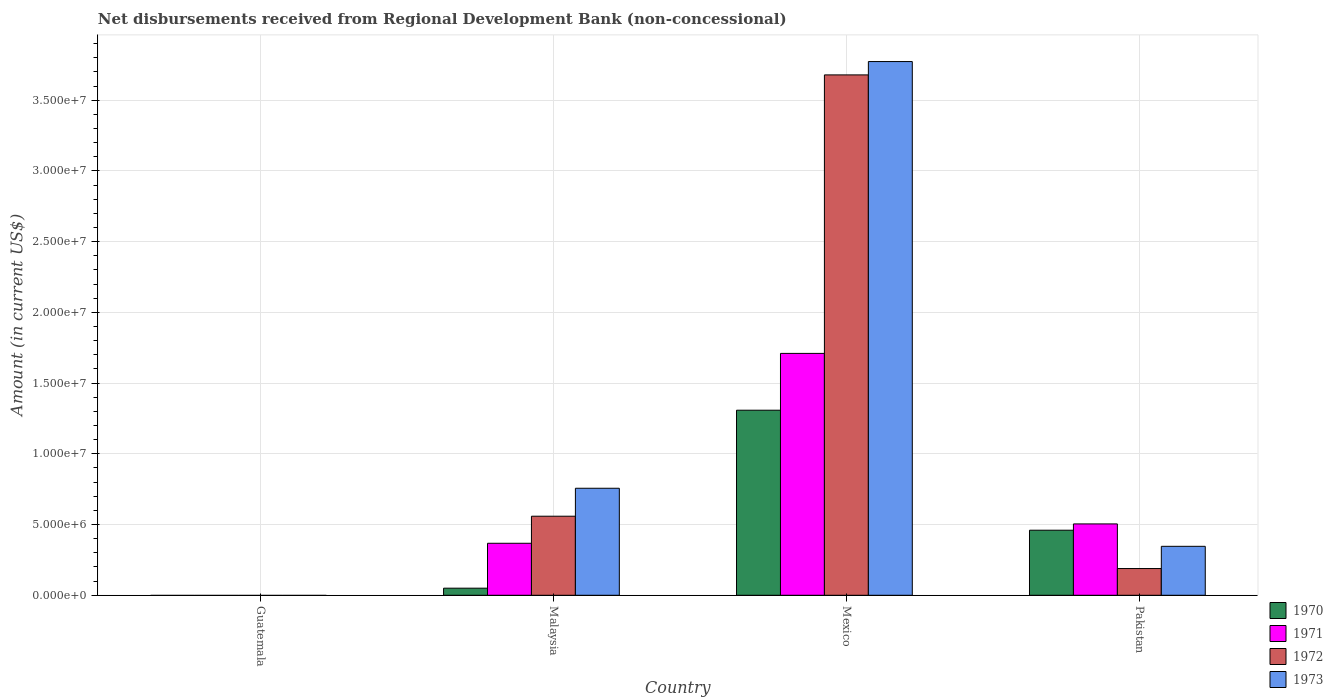How many bars are there on the 2nd tick from the left?
Your answer should be compact. 4. How many bars are there on the 2nd tick from the right?
Keep it short and to the point. 4. What is the amount of disbursements received from Regional Development Bank in 1973 in Mexico?
Your response must be concise. 3.77e+07. Across all countries, what is the maximum amount of disbursements received from Regional Development Bank in 1972?
Keep it short and to the point. 3.68e+07. What is the total amount of disbursements received from Regional Development Bank in 1970 in the graph?
Make the answer very short. 1.82e+07. What is the difference between the amount of disbursements received from Regional Development Bank in 1973 in Malaysia and that in Pakistan?
Your answer should be compact. 4.10e+06. What is the difference between the amount of disbursements received from Regional Development Bank in 1970 in Pakistan and the amount of disbursements received from Regional Development Bank in 1972 in Mexico?
Give a very brief answer. -3.22e+07. What is the average amount of disbursements received from Regional Development Bank in 1971 per country?
Your answer should be very brief. 6.46e+06. What is the difference between the amount of disbursements received from Regional Development Bank of/in 1972 and amount of disbursements received from Regional Development Bank of/in 1971 in Malaysia?
Your answer should be very brief. 1.91e+06. What is the ratio of the amount of disbursements received from Regional Development Bank in 1971 in Mexico to that in Pakistan?
Your response must be concise. 3.39. Is the amount of disbursements received from Regional Development Bank in 1972 in Malaysia less than that in Mexico?
Offer a terse response. Yes. What is the difference between the highest and the second highest amount of disbursements received from Regional Development Bank in 1970?
Your response must be concise. 1.26e+07. What is the difference between the highest and the lowest amount of disbursements received from Regional Development Bank in 1972?
Make the answer very short. 3.68e+07. In how many countries, is the amount of disbursements received from Regional Development Bank in 1970 greater than the average amount of disbursements received from Regional Development Bank in 1970 taken over all countries?
Offer a very short reply. 2. Is it the case that in every country, the sum of the amount of disbursements received from Regional Development Bank in 1972 and amount of disbursements received from Regional Development Bank in 1971 is greater than the sum of amount of disbursements received from Regional Development Bank in 1970 and amount of disbursements received from Regional Development Bank in 1973?
Your answer should be very brief. No. Are all the bars in the graph horizontal?
Give a very brief answer. No. What is the difference between two consecutive major ticks on the Y-axis?
Keep it short and to the point. 5.00e+06. Are the values on the major ticks of Y-axis written in scientific E-notation?
Make the answer very short. Yes. How many legend labels are there?
Keep it short and to the point. 4. How are the legend labels stacked?
Give a very brief answer. Vertical. What is the title of the graph?
Your answer should be very brief. Net disbursements received from Regional Development Bank (non-concessional). Does "1983" appear as one of the legend labels in the graph?
Ensure brevity in your answer.  No. What is the Amount (in current US$) of 1970 in Malaysia?
Your response must be concise. 5.02e+05. What is the Amount (in current US$) in 1971 in Malaysia?
Your answer should be compact. 3.68e+06. What is the Amount (in current US$) in 1972 in Malaysia?
Offer a terse response. 5.59e+06. What is the Amount (in current US$) of 1973 in Malaysia?
Your answer should be very brief. 7.57e+06. What is the Amount (in current US$) of 1970 in Mexico?
Make the answer very short. 1.31e+07. What is the Amount (in current US$) of 1971 in Mexico?
Provide a short and direct response. 1.71e+07. What is the Amount (in current US$) of 1972 in Mexico?
Provide a succinct answer. 3.68e+07. What is the Amount (in current US$) of 1973 in Mexico?
Provide a short and direct response. 3.77e+07. What is the Amount (in current US$) in 1970 in Pakistan?
Make the answer very short. 4.60e+06. What is the Amount (in current US$) in 1971 in Pakistan?
Make the answer very short. 5.04e+06. What is the Amount (in current US$) of 1972 in Pakistan?
Ensure brevity in your answer.  1.89e+06. What is the Amount (in current US$) of 1973 in Pakistan?
Provide a short and direct response. 3.46e+06. Across all countries, what is the maximum Amount (in current US$) in 1970?
Offer a terse response. 1.31e+07. Across all countries, what is the maximum Amount (in current US$) in 1971?
Provide a short and direct response. 1.71e+07. Across all countries, what is the maximum Amount (in current US$) in 1972?
Provide a succinct answer. 3.68e+07. Across all countries, what is the maximum Amount (in current US$) in 1973?
Provide a succinct answer. 3.77e+07. Across all countries, what is the minimum Amount (in current US$) of 1970?
Make the answer very short. 0. Across all countries, what is the minimum Amount (in current US$) of 1971?
Your response must be concise. 0. Across all countries, what is the minimum Amount (in current US$) in 1973?
Offer a very short reply. 0. What is the total Amount (in current US$) in 1970 in the graph?
Ensure brevity in your answer.  1.82e+07. What is the total Amount (in current US$) of 1971 in the graph?
Ensure brevity in your answer.  2.58e+07. What is the total Amount (in current US$) in 1972 in the graph?
Keep it short and to the point. 4.43e+07. What is the total Amount (in current US$) in 1973 in the graph?
Make the answer very short. 4.88e+07. What is the difference between the Amount (in current US$) in 1970 in Malaysia and that in Mexico?
Offer a terse response. -1.26e+07. What is the difference between the Amount (in current US$) of 1971 in Malaysia and that in Mexico?
Offer a very short reply. -1.34e+07. What is the difference between the Amount (in current US$) of 1972 in Malaysia and that in Mexico?
Your response must be concise. -3.12e+07. What is the difference between the Amount (in current US$) in 1973 in Malaysia and that in Mexico?
Provide a short and direct response. -3.02e+07. What is the difference between the Amount (in current US$) in 1970 in Malaysia and that in Pakistan?
Make the answer very short. -4.10e+06. What is the difference between the Amount (in current US$) of 1971 in Malaysia and that in Pakistan?
Your answer should be compact. -1.37e+06. What is the difference between the Amount (in current US$) in 1972 in Malaysia and that in Pakistan?
Make the answer very short. 3.70e+06. What is the difference between the Amount (in current US$) of 1973 in Malaysia and that in Pakistan?
Give a very brief answer. 4.10e+06. What is the difference between the Amount (in current US$) of 1970 in Mexico and that in Pakistan?
Give a very brief answer. 8.48e+06. What is the difference between the Amount (in current US$) of 1971 in Mexico and that in Pakistan?
Ensure brevity in your answer.  1.21e+07. What is the difference between the Amount (in current US$) in 1972 in Mexico and that in Pakistan?
Your answer should be very brief. 3.49e+07. What is the difference between the Amount (in current US$) in 1973 in Mexico and that in Pakistan?
Your response must be concise. 3.43e+07. What is the difference between the Amount (in current US$) in 1970 in Malaysia and the Amount (in current US$) in 1971 in Mexico?
Provide a succinct answer. -1.66e+07. What is the difference between the Amount (in current US$) of 1970 in Malaysia and the Amount (in current US$) of 1972 in Mexico?
Keep it short and to the point. -3.63e+07. What is the difference between the Amount (in current US$) in 1970 in Malaysia and the Amount (in current US$) in 1973 in Mexico?
Your response must be concise. -3.72e+07. What is the difference between the Amount (in current US$) in 1971 in Malaysia and the Amount (in current US$) in 1972 in Mexico?
Your answer should be compact. -3.31e+07. What is the difference between the Amount (in current US$) in 1971 in Malaysia and the Amount (in current US$) in 1973 in Mexico?
Your answer should be very brief. -3.41e+07. What is the difference between the Amount (in current US$) in 1972 in Malaysia and the Amount (in current US$) in 1973 in Mexico?
Your answer should be very brief. -3.21e+07. What is the difference between the Amount (in current US$) of 1970 in Malaysia and the Amount (in current US$) of 1971 in Pakistan?
Provide a short and direct response. -4.54e+06. What is the difference between the Amount (in current US$) of 1970 in Malaysia and the Amount (in current US$) of 1972 in Pakistan?
Your answer should be compact. -1.39e+06. What is the difference between the Amount (in current US$) of 1970 in Malaysia and the Amount (in current US$) of 1973 in Pakistan?
Offer a very short reply. -2.96e+06. What is the difference between the Amount (in current US$) in 1971 in Malaysia and the Amount (in current US$) in 1972 in Pakistan?
Your answer should be very brief. 1.79e+06. What is the difference between the Amount (in current US$) in 1971 in Malaysia and the Amount (in current US$) in 1973 in Pakistan?
Your answer should be very brief. 2.16e+05. What is the difference between the Amount (in current US$) of 1972 in Malaysia and the Amount (in current US$) of 1973 in Pakistan?
Your answer should be compact. 2.13e+06. What is the difference between the Amount (in current US$) of 1970 in Mexico and the Amount (in current US$) of 1971 in Pakistan?
Provide a short and direct response. 8.04e+06. What is the difference between the Amount (in current US$) in 1970 in Mexico and the Amount (in current US$) in 1972 in Pakistan?
Make the answer very short. 1.12e+07. What is the difference between the Amount (in current US$) in 1970 in Mexico and the Amount (in current US$) in 1973 in Pakistan?
Offer a very short reply. 9.62e+06. What is the difference between the Amount (in current US$) in 1971 in Mexico and the Amount (in current US$) in 1972 in Pakistan?
Provide a short and direct response. 1.52e+07. What is the difference between the Amount (in current US$) of 1971 in Mexico and the Amount (in current US$) of 1973 in Pakistan?
Ensure brevity in your answer.  1.36e+07. What is the difference between the Amount (in current US$) in 1972 in Mexico and the Amount (in current US$) in 1973 in Pakistan?
Your answer should be compact. 3.33e+07. What is the average Amount (in current US$) in 1970 per country?
Keep it short and to the point. 4.55e+06. What is the average Amount (in current US$) of 1971 per country?
Your response must be concise. 6.46e+06. What is the average Amount (in current US$) of 1972 per country?
Offer a terse response. 1.11e+07. What is the average Amount (in current US$) in 1973 per country?
Keep it short and to the point. 1.22e+07. What is the difference between the Amount (in current US$) of 1970 and Amount (in current US$) of 1971 in Malaysia?
Give a very brief answer. -3.18e+06. What is the difference between the Amount (in current US$) of 1970 and Amount (in current US$) of 1972 in Malaysia?
Ensure brevity in your answer.  -5.09e+06. What is the difference between the Amount (in current US$) in 1970 and Amount (in current US$) in 1973 in Malaysia?
Your answer should be very brief. -7.06e+06. What is the difference between the Amount (in current US$) of 1971 and Amount (in current US$) of 1972 in Malaysia?
Make the answer very short. -1.91e+06. What is the difference between the Amount (in current US$) of 1971 and Amount (in current US$) of 1973 in Malaysia?
Offer a very short reply. -3.89e+06. What is the difference between the Amount (in current US$) of 1972 and Amount (in current US$) of 1973 in Malaysia?
Offer a terse response. -1.98e+06. What is the difference between the Amount (in current US$) of 1970 and Amount (in current US$) of 1971 in Mexico?
Your answer should be very brief. -4.02e+06. What is the difference between the Amount (in current US$) in 1970 and Amount (in current US$) in 1972 in Mexico?
Ensure brevity in your answer.  -2.37e+07. What is the difference between the Amount (in current US$) in 1970 and Amount (in current US$) in 1973 in Mexico?
Offer a terse response. -2.46e+07. What is the difference between the Amount (in current US$) of 1971 and Amount (in current US$) of 1972 in Mexico?
Your answer should be compact. -1.97e+07. What is the difference between the Amount (in current US$) of 1971 and Amount (in current US$) of 1973 in Mexico?
Ensure brevity in your answer.  -2.06e+07. What is the difference between the Amount (in current US$) of 1972 and Amount (in current US$) of 1973 in Mexico?
Your response must be concise. -9.43e+05. What is the difference between the Amount (in current US$) of 1970 and Amount (in current US$) of 1971 in Pakistan?
Make the answer very short. -4.45e+05. What is the difference between the Amount (in current US$) in 1970 and Amount (in current US$) in 1972 in Pakistan?
Offer a terse response. 2.71e+06. What is the difference between the Amount (in current US$) of 1970 and Amount (in current US$) of 1973 in Pakistan?
Offer a terse response. 1.14e+06. What is the difference between the Amount (in current US$) of 1971 and Amount (in current US$) of 1972 in Pakistan?
Make the answer very short. 3.16e+06. What is the difference between the Amount (in current US$) in 1971 and Amount (in current US$) in 1973 in Pakistan?
Provide a succinct answer. 1.58e+06. What is the difference between the Amount (in current US$) of 1972 and Amount (in current US$) of 1973 in Pakistan?
Your answer should be compact. -1.57e+06. What is the ratio of the Amount (in current US$) in 1970 in Malaysia to that in Mexico?
Offer a very short reply. 0.04. What is the ratio of the Amount (in current US$) of 1971 in Malaysia to that in Mexico?
Provide a succinct answer. 0.21. What is the ratio of the Amount (in current US$) in 1972 in Malaysia to that in Mexico?
Offer a terse response. 0.15. What is the ratio of the Amount (in current US$) in 1973 in Malaysia to that in Mexico?
Offer a very short reply. 0.2. What is the ratio of the Amount (in current US$) of 1970 in Malaysia to that in Pakistan?
Provide a succinct answer. 0.11. What is the ratio of the Amount (in current US$) in 1971 in Malaysia to that in Pakistan?
Provide a succinct answer. 0.73. What is the ratio of the Amount (in current US$) of 1972 in Malaysia to that in Pakistan?
Ensure brevity in your answer.  2.96. What is the ratio of the Amount (in current US$) of 1973 in Malaysia to that in Pakistan?
Give a very brief answer. 2.19. What is the ratio of the Amount (in current US$) in 1970 in Mexico to that in Pakistan?
Provide a succinct answer. 2.84. What is the ratio of the Amount (in current US$) of 1971 in Mexico to that in Pakistan?
Give a very brief answer. 3.39. What is the ratio of the Amount (in current US$) of 1972 in Mexico to that in Pakistan?
Give a very brief answer. 19.47. What is the ratio of the Amount (in current US$) in 1973 in Mexico to that in Pakistan?
Your answer should be compact. 10.9. What is the difference between the highest and the second highest Amount (in current US$) in 1970?
Your answer should be very brief. 8.48e+06. What is the difference between the highest and the second highest Amount (in current US$) of 1971?
Your response must be concise. 1.21e+07. What is the difference between the highest and the second highest Amount (in current US$) in 1972?
Make the answer very short. 3.12e+07. What is the difference between the highest and the second highest Amount (in current US$) in 1973?
Give a very brief answer. 3.02e+07. What is the difference between the highest and the lowest Amount (in current US$) in 1970?
Provide a short and direct response. 1.31e+07. What is the difference between the highest and the lowest Amount (in current US$) in 1971?
Your answer should be compact. 1.71e+07. What is the difference between the highest and the lowest Amount (in current US$) in 1972?
Ensure brevity in your answer.  3.68e+07. What is the difference between the highest and the lowest Amount (in current US$) of 1973?
Keep it short and to the point. 3.77e+07. 